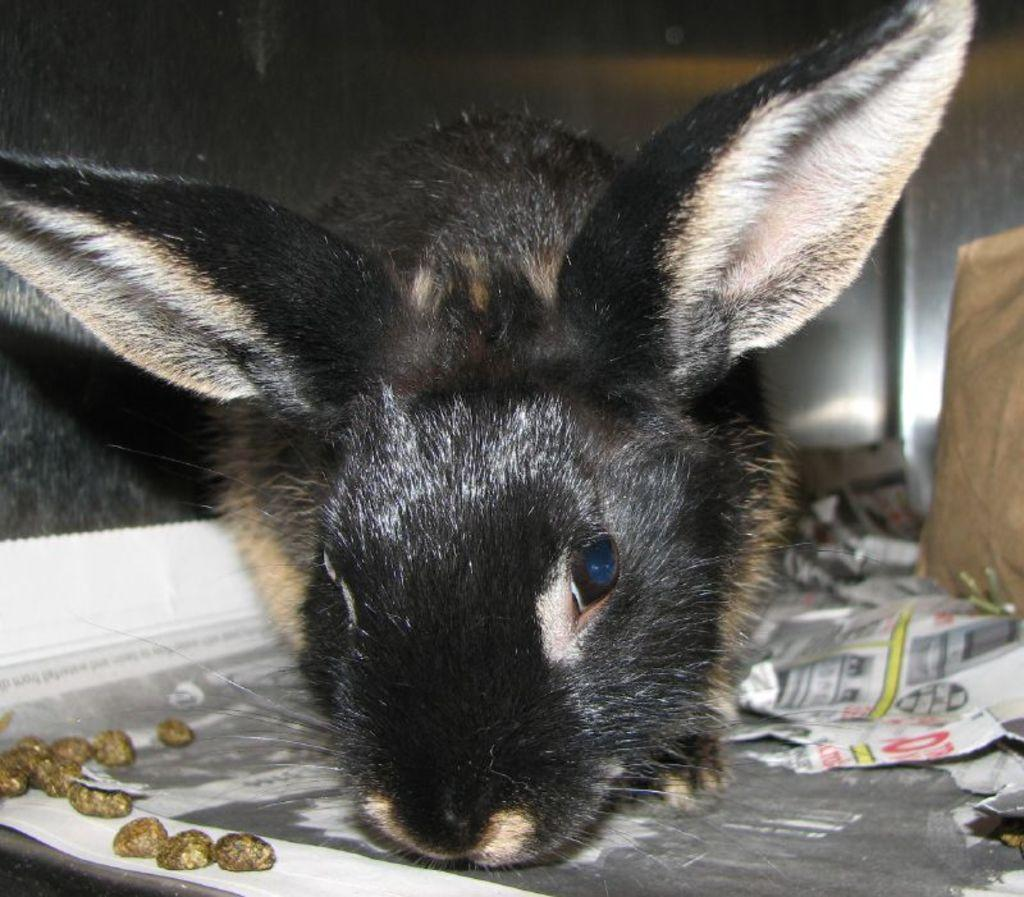What type of animal is in the image? There is an animal in the image, but its specific type cannot be determined from the provided facts. What colors are present on the animal? The animal has black and cream coloring. What else can be seen in the image besides the animal? Papers and objects in brown color are visible in the image. What type of structure is the animal using for treatment in the image? There is no structure or treatment present in the image; it only features an animal with black and cream coloring, papers, and brown objects. 